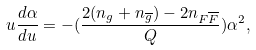<formula> <loc_0><loc_0><loc_500><loc_500>u \frac { d \alpha } { d u } = - ( \frac { 2 ( n _ { g } + n _ { \overline { g } } ) - 2 n _ { F \overline { F } } } { Q } ) \alpha ^ { 2 } ,</formula> 